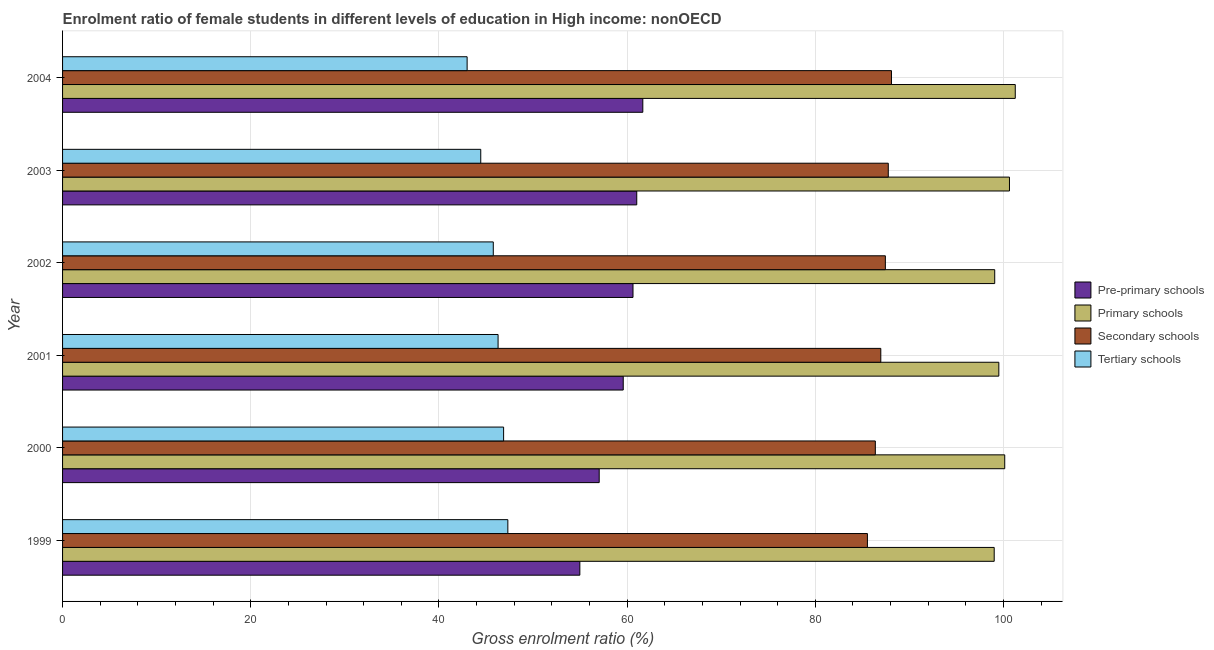How many groups of bars are there?
Your answer should be compact. 6. Are the number of bars per tick equal to the number of legend labels?
Make the answer very short. Yes. Are the number of bars on each tick of the Y-axis equal?
Your answer should be compact. Yes. How many bars are there on the 2nd tick from the top?
Offer a terse response. 4. How many bars are there on the 2nd tick from the bottom?
Provide a succinct answer. 4. What is the label of the 6th group of bars from the top?
Keep it short and to the point. 1999. In how many cases, is the number of bars for a given year not equal to the number of legend labels?
Keep it short and to the point. 0. What is the gross enrolment ratio(male) in secondary schools in 2003?
Offer a very short reply. 87.75. Across all years, what is the maximum gross enrolment ratio(male) in tertiary schools?
Provide a succinct answer. 47.32. Across all years, what is the minimum gross enrolment ratio(male) in pre-primary schools?
Offer a very short reply. 54.98. What is the total gross enrolment ratio(male) in secondary schools in the graph?
Provide a succinct answer. 522.16. What is the difference between the gross enrolment ratio(male) in pre-primary schools in 2001 and that in 2003?
Keep it short and to the point. -1.44. What is the difference between the gross enrolment ratio(male) in pre-primary schools in 2000 and the gross enrolment ratio(male) in tertiary schools in 2003?
Give a very brief answer. 12.59. What is the average gross enrolment ratio(male) in pre-primary schools per year?
Offer a terse response. 59.15. In the year 2002, what is the difference between the gross enrolment ratio(male) in primary schools and gross enrolment ratio(male) in tertiary schools?
Provide a succinct answer. 53.29. What is the ratio of the gross enrolment ratio(male) in pre-primary schools in 1999 to that in 2004?
Offer a very short reply. 0.89. Is the gross enrolment ratio(male) in tertiary schools in 2002 less than that in 2004?
Make the answer very short. No. What is the difference between the highest and the second highest gross enrolment ratio(male) in tertiary schools?
Ensure brevity in your answer.  0.45. What is the difference between the highest and the lowest gross enrolment ratio(male) in pre-primary schools?
Provide a succinct answer. 6.69. Is the sum of the gross enrolment ratio(male) in primary schools in 2000 and 2003 greater than the maximum gross enrolment ratio(male) in tertiary schools across all years?
Make the answer very short. Yes. Is it the case that in every year, the sum of the gross enrolment ratio(male) in pre-primary schools and gross enrolment ratio(male) in secondary schools is greater than the sum of gross enrolment ratio(male) in primary schools and gross enrolment ratio(male) in tertiary schools?
Offer a terse response. No. What does the 1st bar from the top in 2000 represents?
Give a very brief answer. Tertiary schools. What does the 3rd bar from the bottom in 2003 represents?
Keep it short and to the point. Secondary schools. How many years are there in the graph?
Provide a short and direct response. 6. Are the values on the major ticks of X-axis written in scientific E-notation?
Offer a terse response. No. Does the graph contain any zero values?
Your answer should be compact. No. How many legend labels are there?
Your answer should be compact. 4. How are the legend labels stacked?
Ensure brevity in your answer.  Vertical. What is the title of the graph?
Make the answer very short. Enrolment ratio of female students in different levels of education in High income: nonOECD. What is the Gross enrolment ratio (%) of Pre-primary schools in 1999?
Offer a terse response. 54.98. What is the Gross enrolment ratio (%) of Primary schools in 1999?
Provide a succinct answer. 99.01. What is the Gross enrolment ratio (%) in Secondary schools in 1999?
Provide a succinct answer. 85.54. What is the Gross enrolment ratio (%) in Tertiary schools in 1999?
Offer a very short reply. 47.32. What is the Gross enrolment ratio (%) in Pre-primary schools in 2000?
Your answer should be very brief. 57.03. What is the Gross enrolment ratio (%) in Primary schools in 2000?
Give a very brief answer. 100.13. What is the Gross enrolment ratio (%) of Secondary schools in 2000?
Your answer should be compact. 86.38. What is the Gross enrolment ratio (%) of Tertiary schools in 2000?
Keep it short and to the point. 46.87. What is the Gross enrolment ratio (%) in Pre-primary schools in 2001?
Make the answer very short. 59.59. What is the Gross enrolment ratio (%) in Primary schools in 2001?
Ensure brevity in your answer.  99.5. What is the Gross enrolment ratio (%) in Secondary schools in 2001?
Make the answer very short. 86.96. What is the Gross enrolment ratio (%) of Tertiary schools in 2001?
Provide a short and direct response. 46.29. What is the Gross enrolment ratio (%) in Pre-primary schools in 2002?
Offer a terse response. 60.62. What is the Gross enrolment ratio (%) in Primary schools in 2002?
Offer a terse response. 99.07. What is the Gross enrolment ratio (%) of Secondary schools in 2002?
Your answer should be compact. 87.44. What is the Gross enrolment ratio (%) of Tertiary schools in 2002?
Offer a very short reply. 45.78. What is the Gross enrolment ratio (%) in Pre-primary schools in 2003?
Make the answer very short. 61.02. What is the Gross enrolment ratio (%) in Primary schools in 2003?
Your response must be concise. 100.63. What is the Gross enrolment ratio (%) of Secondary schools in 2003?
Offer a very short reply. 87.75. What is the Gross enrolment ratio (%) in Tertiary schools in 2003?
Offer a very short reply. 44.44. What is the Gross enrolment ratio (%) of Pre-primary schools in 2004?
Give a very brief answer. 61.67. What is the Gross enrolment ratio (%) in Primary schools in 2004?
Your answer should be very brief. 101.25. What is the Gross enrolment ratio (%) of Secondary schools in 2004?
Give a very brief answer. 88.09. What is the Gross enrolment ratio (%) in Tertiary schools in 2004?
Provide a short and direct response. 42.99. Across all years, what is the maximum Gross enrolment ratio (%) of Pre-primary schools?
Your answer should be compact. 61.67. Across all years, what is the maximum Gross enrolment ratio (%) of Primary schools?
Give a very brief answer. 101.25. Across all years, what is the maximum Gross enrolment ratio (%) of Secondary schools?
Your answer should be very brief. 88.09. Across all years, what is the maximum Gross enrolment ratio (%) of Tertiary schools?
Give a very brief answer. 47.32. Across all years, what is the minimum Gross enrolment ratio (%) in Pre-primary schools?
Your response must be concise. 54.98. Across all years, what is the minimum Gross enrolment ratio (%) in Primary schools?
Make the answer very short. 99.01. Across all years, what is the minimum Gross enrolment ratio (%) of Secondary schools?
Your answer should be very brief. 85.54. Across all years, what is the minimum Gross enrolment ratio (%) of Tertiary schools?
Offer a terse response. 42.99. What is the total Gross enrolment ratio (%) in Pre-primary schools in the graph?
Your answer should be compact. 354.91. What is the total Gross enrolment ratio (%) of Primary schools in the graph?
Make the answer very short. 599.59. What is the total Gross enrolment ratio (%) of Secondary schools in the graph?
Keep it short and to the point. 522.16. What is the total Gross enrolment ratio (%) of Tertiary schools in the graph?
Provide a short and direct response. 273.69. What is the difference between the Gross enrolment ratio (%) of Pre-primary schools in 1999 and that in 2000?
Provide a succinct answer. -2.06. What is the difference between the Gross enrolment ratio (%) of Primary schools in 1999 and that in 2000?
Offer a very short reply. -1.12. What is the difference between the Gross enrolment ratio (%) in Secondary schools in 1999 and that in 2000?
Offer a very short reply. -0.84. What is the difference between the Gross enrolment ratio (%) of Tertiary schools in 1999 and that in 2000?
Your answer should be very brief. 0.45. What is the difference between the Gross enrolment ratio (%) of Pre-primary schools in 1999 and that in 2001?
Offer a terse response. -4.61. What is the difference between the Gross enrolment ratio (%) of Primary schools in 1999 and that in 2001?
Your answer should be compact. -0.49. What is the difference between the Gross enrolment ratio (%) of Secondary schools in 1999 and that in 2001?
Offer a very short reply. -1.42. What is the difference between the Gross enrolment ratio (%) of Tertiary schools in 1999 and that in 2001?
Keep it short and to the point. 1.04. What is the difference between the Gross enrolment ratio (%) in Pre-primary schools in 1999 and that in 2002?
Keep it short and to the point. -5.65. What is the difference between the Gross enrolment ratio (%) of Primary schools in 1999 and that in 2002?
Your answer should be compact. -0.05. What is the difference between the Gross enrolment ratio (%) of Secondary schools in 1999 and that in 2002?
Make the answer very short. -1.91. What is the difference between the Gross enrolment ratio (%) of Tertiary schools in 1999 and that in 2002?
Provide a short and direct response. 1.55. What is the difference between the Gross enrolment ratio (%) in Pre-primary schools in 1999 and that in 2003?
Make the answer very short. -6.05. What is the difference between the Gross enrolment ratio (%) of Primary schools in 1999 and that in 2003?
Your response must be concise. -1.62. What is the difference between the Gross enrolment ratio (%) in Secondary schools in 1999 and that in 2003?
Make the answer very short. -2.22. What is the difference between the Gross enrolment ratio (%) in Tertiary schools in 1999 and that in 2003?
Give a very brief answer. 2.88. What is the difference between the Gross enrolment ratio (%) in Pre-primary schools in 1999 and that in 2004?
Your answer should be very brief. -6.69. What is the difference between the Gross enrolment ratio (%) in Primary schools in 1999 and that in 2004?
Your answer should be very brief. -2.24. What is the difference between the Gross enrolment ratio (%) of Secondary schools in 1999 and that in 2004?
Keep it short and to the point. -2.56. What is the difference between the Gross enrolment ratio (%) in Tertiary schools in 1999 and that in 2004?
Make the answer very short. 4.33. What is the difference between the Gross enrolment ratio (%) of Pre-primary schools in 2000 and that in 2001?
Ensure brevity in your answer.  -2.55. What is the difference between the Gross enrolment ratio (%) in Primary schools in 2000 and that in 2001?
Keep it short and to the point. 0.63. What is the difference between the Gross enrolment ratio (%) in Secondary schools in 2000 and that in 2001?
Offer a very short reply. -0.58. What is the difference between the Gross enrolment ratio (%) of Tertiary schools in 2000 and that in 2001?
Give a very brief answer. 0.59. What is the difference between the Gross enrolment ratio (%) in Pre-primary schools in 2000 and that in 2002?
Make the answer very short. -3.59. What is the difference between the Gross enrolment ratio (%) of Primary schools in 2000 and that in 2002?
Your answer should be very brief. 1.06. What is the difference between the Gross enrolment ratio (%) of Secondary schools in 2000 and that in 2002?
Give a very brief answer. -1.07. What is the difference between the Gross enrolment ratio (%) of Tertiary schools in 2000 and that in 2002?
Make the answer very short. 1.1. What is the difference between the Gross enrolment ratio (%) of Pre-primary schools in 2000 and that in 2003?
Give a very brief answer. -3.99. What is the difference between the Gross enrolment ratio (%) in Primary schools in 2000 and that in 2003?
Provide a short and direct response. -0.5. What is the difference between the Gross enrolment ratio (%) of Secondary schools in 2000 and that in 2003?
Your answer should be very brief. -1.38. What is the difference between the Gross enrolment ratio (%) in Tertiary schools in 2000 and that in 2003?
Your answer should be very brief. 2.43. What is the difference between the Gross enrolment ratio (%) of Pre-primary schools in 2000 and that in 2004?
Make the answer very short. -4.63. What is the difference between the Gross enrolment ratio (%) in Primary schools in 2000 and that in 2004?
Your response must be concise. -1.12. What is the difference between the Gross enrolment ratio (%) of Secondary schools in 2000 and that in 2004?
Offer a very short reply. -1.71. What is the difference between the Gross enrolment ratio (%) in Tertiary schools in 2000 and that in 2004?
Keep it short and to the point. 3.88. What is the difference between the Gross enrolment ratio (%) of Pre-primary schools in 2001 and that in 2002?
Your answer should be very brief. -1.04. What is the difference between the Gross enrolment ratio (%) in Primary schools in 2001 and that in 2002?
Your answer should be very brief. 0.44. What is the difference between the Gross enrolment ratio (%) in Secondary schools in 2001 and that in 2002?
Provide a succinct answer. -0.48. What is the difference between the Gross enrolment ratio (%) in Tertiary schools in 2001 and that in 2002?
Your answer should be compact. 0.51. What is the difference between the Gross enrolment ratio (%) of Pre-primary schools in 2001 and that in 2003?
Your answer should be very brief. -1.44. What is the difference between the Gross enrolment ratio (%) in Primary schools in 2001 and that in 2003?
Ensure brevity in your answer.  -1.13. What is the difference between the Gross enrolment ratio (%) in Secondary schools in 2001 and that in 2003?
Offer a terse response. -0.8. What is the difference between the Gross enrolment ratio (%) of Tertiary schools in 2001 and that in 2003?
Your answer should be very brief. 1.84. What is the difference between the Gross enrolment ratio (%) of Pre-primary schools in 2001 and that in 2004?
Provide a succinct answer. -2.08. What is the difference between the Gross enrolment ratio (%) of Primary schools in 2001 and that in 2004?
Provide a short and direct response. -1.75. What is the difference between the Gross enrolment ratio (%) of Secondary schools in 2001 and that in 2004?
Keep it short and to the point. -1.13. What is the difference between the Gross enrolment ratio (%) of Tertiary schools in 2001 and that in 2004?
Give a very brief answer. 3.29. What is the difference between the Gross enrolment ratio (%) in Pre-primary schools in 2002 and that in 2003?
Offer a very short reply. -0.4. What is the difference between the Gross enrolment ratio (%) of Primary schools in 2002 and that in 2003?
Make the answer very short. -1.57. What is the difference between the Gross enrolment ratio (%) of Secondary schools in 2002 and that in 2003?
Your answer should be compact. -0.31. What is the difference between the Gross enrolment ratio (%) in Tertiary schools in 2002 and that in 2003?
Make the answer very short. 1.33. What is the difference between the Gross enrolment ratio (%) of Pre-primary schools in 2002 and that in 2004?
Your answer should be very brief. -1.04. What is the difference between the Gross enrolment ratio (%) in Primary schools in 2002 and that in 2004?
Offer a very short reply. -2.18. What is the difference between the Gross enrolment ratio (%) of Secondary schools in 2002 and that in 2004?
Make the answer very short. -0.65. What is the difference between the Gross enrolment ratio (%) of Tertiary schools in 2002 and that in 2004?
Provide a succinct answer. 2.78. What is the difference between the Gross enrolment ratio (%) in Pre-primary schools in 2003 and that in 2004?
Give a very brief answer. -0.64. What is the difference between the Gross enrolment ratio (%) of Primary schools in 2003 and that in 2004?
Your response must be concise. -0.62. What is the difference between the Gross enrolment ratio (%) in Secondary schools in 2003 and that in 2004?
Your response must be concise. -0.34. What is the difference between the Gross enrolment ratio (%) of Tertiary schools in 2003 and that in 2004?
Provide a short and direct response. 1.45. What is the difference between the Gross enrolment ratio (%) of Pre-primary schools in 1999 and the Gross enrolment ratio (%) of Primary schools in 2000?
Provide a succinct answer. -45.16. What is the difference between the Gross enrolment ratio (%) of Pre-primary schools in 1999 and the Gross enrolment ratio (%) of Secondary schools in 2000?
Your answer should be very brief. -31.4. What is the difference between the Gross enrolment ratio (%) of Pre-primary schools in 1999 and the Gross enrolment ratio (%) of Tertiary schools in 2000?
Make the answer very short. 8.1. What is the difference between the Gross enrolment ratio (%) of Primary schools in 1999 and the Gross enrolment ratio (%) of Secondary schools in 2000?
Give a very brief answer. 12.63. What is the difference between the Gross enrolment ratio (%) in Primary schools in 1999 and the Gross enrolment ratio (%) in Tertiary schools in 2000?
Your response must be concise. 52.14. What is the difference between the Gross enrolment ratio (%) of Secondary schools in 1999 and the Gross enrolment ratio (%) of Tertiary schools in 2000?
Make the answer very short. 38.66. What is the difference between the Gross enrolment ratio (%) in Pre-primary schools in 1999 and the Gross enrolment ratio (%) in Primary schools in 2001?
Ensure brevity in your answer.  -44.53. What is the difference between the Gross enrolment ratio (%) in Pre-primary schools in 1999 and the Gross enrolment ratio (%) in Secondary schools in 2001?
Your answer should be compact. -31.98. What is the difference between the Gross enrolment ratio (%) of Pre-primary schools in 1999 and the Gross enrolment ratio (%) of Tertiary schools in 2001?
Give a very brief answer. 8.69. What is the difference between the Gross enrolment ratio (%) of Primary schools in 1999 and the Gross enrolment ratio (%) of Secondary schools in 2001?
Your answer should be compact. 12.05. What is the difference between the Gross enrolment ratio (%) in Primary schools in 1999 and the Gross enrolment ratio (%) in Tertiary schools in 2001?
Give a very brief answer. 52.73. What is the difference between the Gross enrolment ratio (%) in Secondary schools in 1999 and the Gross enrolment ratio (%) in Tertiary schools in 2001?
Your answer should be compact. 39.25. What is the difference between the Gross enrolment ratio (%) of Pre-primary schools in 1999 and the Gross enrolment ratio (%) of Primary schools in 2002?
Provide a short and direct response. -44.09. What is the difference between the Gross enrolment ratio (%) of Pre-primary schools in 1999 and the Gross enrolment ratio (%) of Secondary schools in 2002?
Provide a short and direct response. -32.47. What is the difference between the Gross enrolment ratio (%) in Pre-primary schools in 1999 and the Gross enrolment ratio (%) in Tertiary schools in 2002?
Make the answer very short. 9.2. What is the difference between the Gross enrolment ratio (%) in Primary schools in 1999 and the Gross enrolment ratio (%) in Secondary schools in 2002?
Offer a terse response. 11.57. What is the difference between the Gross enrolment ratio (%) of Primary schools in 1999 and the Gross enrolment ratio (%) of Tertiary schools in 2002?
Make the answer very short. 53.24. What is the difference between the Gross enrolment ratio (%) of Secondary schools in 1999 and the Gross enrolment ratio (%) of Tertiary schools in 2002?
Your answer should be compact. 39.76. What is the difference between the Gross enrolment ratio (%) of Pre-primary schools in 1999 and the Gross enrolment ratio (%) of Primary schools in 2003?
Your answer should be compact. -45.66. What is the difference between the Gross enrolment ratio (%) of Pre-primary schools in 1999 and the Gross enrolment ratio (%) of Secondary schools in 2003?
Your response must be concise. -32.78. What is the difference between the Gross enrolment ratio (%) of Pre-primary schools in 1999 and the Gross enrolment ratio (%) of Tertiary schools in 2003?
Ensure brevity in your answer.  10.53. What is the difference between the Gross enrolment ratio (%) of Primary schools in 1999 and the Gross enrolment ratio (%) of Secondary schools in 2003?
Your answer should be compact. 11.26. What is the difference between the Gross enrolment ratio (%) in Primary schools in 1999 and the Gross enrolment ratio (%) in Tertiary schools in 2003?
Your answer should be compact. 54.57. What is the difference between the Gross enrolment ratio (%) in Secondary schools in 1999 and the Gross enrolment ratio (%) in Tertiary schools in 2003?
Keep it short and to the point. 41.09. What is the difference between the Gross enrolment ratio (%) of Pre-primary schools in 1999 and the Gross enrolment ratio (%) of Primary schools in 2004?
Your response must be concise. -46.27. What is the difference between the Gross enrolment ratio (%) of Pre-primary schools in 1999 and the Gross enrolment ratio (%) of Secondary schools in 2004?
Offer a very short reply. -33.12. What is the difference between the Gross enrolment ratio (%) in Pre-primary schools in 1999 and the Gross enrolment ratio (%) in Tertiary schools in 2004?
Give a very brief answer. 11.98. What is the difference between the Gross enrolment ratio (%) in Primary schools in 1999 and the Gross enrolment ratio (%) in Secondary schools in 2004?
Give a very brief answer. 10.92. What is the difference between the Gross enrolment ratio (%) of Primary schools in 1999 and the Gross enrolment ratio (%) of Tertiary schools in 2004?
Provide a succinct answer. 56.02. What is the difference between the Gross enrolment ratio (%) of Secondary schools in 1999 and the Gross enrolment ratio (%) of Tertiary schools in 2004?
Your answer should be very brief. 42.54. What is the difference between the Gross enrolment ratio (%) in Pre-primary schools in 2000 and the Gross enrolment ratio (%) in Primary schools in 2001?
Provide a succinct answer. -42.47. What is the difference between the Gross enrolment ratio (%) in Pre-primary schools in 2000 and the Gross enrolment ratio (%) in Secondary schools in 2001?
Offer a very short reply. -29.93. What is the difference between the Gross enrolment ratio (%) in Pre-primary schools in 2000 and the Gross enrolment ratio (%) in Tertiary schools in 2001?
Provide a succinct answer. 10.75. What is the difference between the Gross enrolment ratio (%) in Primary schools in 2000 and the Gross enrolment ratio (%) in Secondary schools in 2001?
Ensure brevity in your answer.  13.17. What is the difference between the Gross enrolment ratio (%) in Primary schools in 2000 and the Gross enrolment ratio (%) in Tertiary schools in 2001?
Ensure brevity in your answer.  53.85. What is the difference between the Gross enrolment ratio (%) in Secondary schools in 2000 and the Gross enrolment ratio (%) in Tertiary schools in 2001?
Your response must be concise. 40.09. What is the difference between the Gross enrolment ratio (%) of Pre-primary schools in 2000 and the Gross enrolment ratio (%) of Primary schools in 2002?
Ensure brevity in your answer.  -42.03. What is the difference between the Gross enrolment ratio (%) in Pre-primary schools in 2000 and the Gross enrolment ratio (%) in Secondary schools in 2002?
Your answer should be very brief. -30.41. What is the difference between the Gross enrolment ratio (%) of Pre-primary schools in 2000 and the Gross enrolment ratio (%) of Tertiary schools in 2002?
Your answer should be compact. 11.26. What is the difference between the Gross enrolment ratio (%) in Primary schools in 2000 and the Gross enrolment ratio (%) in Secondary schools in 2002?
Your answer should be compact. 12.69. What is the difference between the Gross enrolment ratio (%) of Primary schools in 2000 and the Gross enrolment ratio (%) of Tertiary schools in 2002?
Give a very brief answer. 54.35. What is the difference between the Gross enrolment ratio (%) in Secondary schools in 2000 and the Gross enrolment ratio (%) in Tertiary schools in 2002?
Provide a succinct answer. 40.6. What is the difference between the Gross enrolment ratio (%) of Pre-primary schools in 2000 and the Gross enrolment ratio (%) of Primary schools in 2003?
Offer a very short reply. -43.6. What is the difference between the Gross enrolment ratio (%) in Pre-primary schools in 2000 and the Gross enrolment ratio (%) in Secondary schools in 2003?
Your answer should be very brief. -30.72. What is the difference between the Gross enrolment ratio (%) in Pre-primary schools in 2000 and the Gross enrolment ratio (%) in Tertiary schools in 2003?
Give a very brief answer. 12.59. What is the difference between the Gross enrolment ratio (%) of Primary schools in 2000 and the Gross enrolment ratio (%) of Secondary schools in 2003?
Give a very brief answer. 12.38. What is the difference between the Gross enrolment ratio (%) in Primary schools in 2000 and the Gross enrolment ratio (%) in Tertiary schools in 2003?
Provide a short and direct response. 55.69. What is the difference between the Gross enrolment ratio (%) of Secondary schools in 2000 and the Gross enrolment ratio (%) of Tertiary schools in 2003?
Give a very brief answer. 41.93. What is the difference between the Gross enrolment ratio (%) of Pre-primary schools in 2000 and the Gross enrolment ratio (%) of Primary schools in 2004?
Provide a succinct answer. -44.22. What is the difference between the Gross enrolment ratio (%) of Pre-primary schools in 2000 and the Gross enrolment ratio (%) of Secondary schools in 2004?
Offer a terse response. -31.06. What is the difference between the Gross enrolment ratio (%) of Pre-primary schools in 2000 and the Gross enrolment ratio (%) of Tertiary schools in 2004?
Give a very brief answer. 14.04. What is the difference between the Gross enrolment ratio (%) of Primary schools in 2000 and the Gross enrolment ratio (%) of Secondary schools in 2004?
Provide a short and direct response. 12.04. What is the difference between the Gross enrolment ratio (%) in Primary schools in 2000 and the Gross enrolment ratio (%) in Tertiary schools in 2004?
Your response must be concise. 57.14. What is the difference between the Gross enrolment ratio (%) of Secondary schools in 2000 and the Gross enrolment ratio (%) of Tertiary schools in 2004?
Ensure brevity in your answer.  43.38. What is the difference between the Gross enrolment ratio (%) of Pre-primary schools in 2001 and the Gross enrolment ratio (%) of Primary schools in 2002?
Provide a succinct answer. -39.48. What is the difference between the Gross enrolment ratio (%) in Pre-primary schools in 2001 and the Gross enrolment ratio (%) in Secondary schools in 2002?
Your answer should be compact. -27.86. What is the difference between the Gross enrolment ratio (%) in Pre-primary schools in 2001 and the Gross enrolment ratio (%) in Tertiary schools in 2002?
Your answer should be compact. 13.81. What is the difference between the Gross enrolment ratio (%) of Primary schools in 2001 and the Gross enrolment ratio (%) of Secondary schools in 2002?
Ensure brevity in your answer.  12.06. What is the difference between the Gross enrolment ratio (%) of Primary schools in 2001 and the Gross enrolment ratio (%) of Tertiary schools in 2002?
Ensure brevity in your answer.  53.73. What is the difference between the Gross enrolment ratio (%) of Secondary schools in 2001 and the Gross enrolment ratio (%) of Tertiary schools in 2002?
Provide a succinct answer. 41.18. What is the difference between the Gross enrolment ratio (%) in Pre-primary schools in 2001 and the Gross enrolment ratio (%) in Primary schools in 2003?
Make the answer very short. -41.05. What is the difference between the Gross enrolment ratio (%) of Pre-primary schools in 2001 and the Gross enrolment ratio (%) of Secondary schools in 2003?
Your answer should be compact. -28.17. What is the difference between the Gross enrolment ratio (%) in Pre-primary schools in 2001 and the Gross enrolment ratio (%) in Tertiary schools in 2003?
Give a very brief answer. 15.14. What is the difference between the Gross enrolment ratio (%) of Primary schools in 2001 and the Gross enrolment ratio (%) of Secondary schools in 2003?
Your answer should be compact. 11.75. What is the difference between the Gross enrolment ratio (%) in Primary schools in 2001 and the Gross enrolment ratio (%) in Tertiary schools in 2003?
Your answer should be compact. 55.06. What is the difference between the Gross enrolment ratio (%) in Secondary schools in 2001 and the Gross enrolment ratio (%) in Tertiary schools in 2003?
Ensure brevity in your answer.  42.52. What is the difference between the Gross enrolment ratio (%) in Pre-primary schools in 2001 and the Gross enrolment ratio (%) in Primary schools in 2004?
Your response must be concise. -41.66. What is the difference between the Gross enrolment ratio (%) in Pre-primary schools in 2001 and the Gross enrolment ratio (%) in Secondary schools in 2004?
Make the answer very short. -28.51. What is the difference between the Gross enrolment ratio (%) in Pre-primary schools in 2001 and the Gross enrolment ratio (%) in Tertiary schools in 2004?
Offer a very short reply. 16.59. What is the difference between the Gross enrolment ratio (%) of Primary schools in 2001 and the Gross enrolment ratio (%) of Secondary schools in 2004?
Your answer should be compact. 11.41. What is the difference between the Gross enrolment ratio (%) of Primary schools in 2001 and the Gross enrolment ratio (%) of Tertiary schools in 2004?
Give a very brief answer. 56.51. What is the difference between the Gross enrolment ratio (%) in Secondary schools in 2001 and the Gross enrolment ratio (%) in Tertiary schools in 2004?
Keep it short and to the point. 43.96. What is the difference between the Gross enrolment ratio (%) in Pre-primary schools in 2002 and the Gross enrolment ratio (%) in Primary schools in 2003?
Give a very brief answer. -40.01. What is the difference between the Gross enrolment ratio (%) of Pre-primary schools in 2002 and the Gross enrolment ratio (%) of Secondary schools in 2003?
Keep it short and to the point. -27.13. What is the difference between the Gross enrolment ratio (%) in Pre-primary schools in 2002 and the Gross enrolment ratio (%) in Tertiary schools in 2003?
Provide a short and direct response. 16.18. What is the difference between the Gross enrolment ratio (%) in Primary schools in 2002 and the Gross enrolment ratio (%) in Secondary schools in 2003?
Make the answer very short. 11.31. What is the difference between the Gross enrolment ratio (%) in Primary schools in 2002 and the Gross enrolment ratio (%) in Tertiary schools in 2003?
Give a very brief answer. 54.62. What is the difference between the Gross enrolment ratio (%) in Secondary schools in 2002 and the Gross enrolment ratio (%) in Tertiary schools in 2003?
Your answer should be very brief. 43. What is the difference between the Gross enrolment ratio (%) of Pre-primary schools in 2002 and the Gross enrolment ratio (%) of Primary schools in 2004?
Offer a terse response. -40.63. What is the difference between the Gross enrolment ratio (%) of Pre-primary schools in 2002 and the Gross enrolment ratio (%) of Secondary schools in 2004?
Your response must be concise. -27.47. What is the difference between the Gross enrolment ratio (%) in Pre-primary schools in 2002 and the Gross enrolment ratio (%) in Tertiary schools in 2004?
Keep it short and to the point. 17.63. What is the difference between the Gross enrolment ratio (%) of Primary schools in 2002 and the Gross enrolment ratio (%) of Secondary schools in 2004?
Offer a terse response. 10.97. What is the difference between the Gross enrolment ratio (%) of Primary schools in 2002 and the Gross enrolment ratio (%) of Tertiary schools in 2004?
Provide a succinct answer. 56.07. What is the difference between the Gross enrolment ratio (%) in Secondary schools in 2002 and the Gross enrolment ratio (%) in Tertiary schools in 2004?
Your response must be concise. 44.45. What is the difference between the Gross enrolment ratio (%) of Pre-primary schools in 2003 and the Gross enrolment ratio (%) of Primary schools in 2004?
Offer a very short reply. -40.23. What is the difference between the Gross enrolment ratio (%) in Pre-primary schools in 2003 and the Gross enrolment ratio (%) in Secondary schools in 2004?
Offer a terse response. -27.07. What is the difference between the Gross enrolment ratio (%) of Pre-primary schools in 2003 and the Gross enrolment ratio (%) of Tertiary schools in 2004?
Your answer should be compact. 18.03. What is the difference between the Gross enrolment ratio (%) of Primary schools in 2003 and the Gross enrolment ratio (%) of Secondary schools in 2004?
Your response must be concise. 12.54. What is the difference between the Gross enrolment ratio (%) of Primary schools in 2003 and the Gross enrolment ratio (%) of Tertiary schools in 2004?
Your response must be concise. 57.64. What is the difference between the Gross enrolment ratio (%) of Secondary schools in 2003 and the Gross enrolment ratio (%) of Tertiary schools in 2004?
Give a very brief answer. 44.76. What is the average Gross enrolment ratio (%) of Pre-primary schools per year?
Ensure brevity in your answer.  59.15. What is the average Gross enrolment ratio (%) of Primary schools per year?
Ensure brevity in your answer.  99.93. What is the average Gross enrolment ratio (%) of Secondary schools per year?
Offer a terse response. 87.03. What is the average Gross enrolment ratio (%) in Tertiary schools per year?
Your response must be concise. 45.62. In the year 1999, what is the difference between the Gross enrolment ratio (%) of Pre-primary schools and Gross enrolment ratio (%) of Primary schools?
Keep it short and to the point. -44.04. In the year 1999, what is the difference between the Gross enrolment ratio (%) of Pre-primary schools and Gross enrolment ratio (%) of Secondary schools?
Your response must be concise. -30.56. In the year 1999, what is the difference between the Gross enrolment ratio (%) of Pre-primary schools and Gross enrolment ratio (%) of Tertiary schools?
Make the answer very short. 7.65. In the year 1999, what is the difference between the Gross enrolment ratio (%) in Primary schools and Gross enrolment ratio (%) in Secondary schools?
Your answer should be very brief. 13.47. In the year 1999, what is the difference between the Gross enrolment ratio (%) of Primary schools and Gross enrolment ratio (%) of Tertiary schools?
Your response must be concise. 51.69. In the year 1999, what is the difference between the Gross enrolment ratio (%) in Secondary schools and Gross enrolment ratio (%) in Tertiary schools?
Ensure brevity in your answer.  38.21. In the year 2000, what is the difference between the Gross enrolment ratio (%) of Pre-primary schools and Gross enrolment ratio (%) of Primary schools?
Provide a short and direct response. -43.1. In the year 2000, what is the difference between the Gross enrolment ratio (%) of Pre-primary schools and Gross enrolment ratio (%) of Secondary schools?
Keep it short and to the point. -29.35. In the year 2000, what is the difference between the Gross enrolment ratio (%) of Pre-primary schools and Gross enrolment ratio (%) of Tertiary schools?
Your response must be concise. 10.16. In the year 2000, what is the difference between the Gross enrolment ratio (%) of Primary schools and Gross enrolment ratio (%) of Secondary schools?
Your response must be concise. 13.75. In the year 2000, what is the difference between the Gross enrolment ratio (%) in Primary schools and Gross enrolment ratio (%) in Tertiary schools?
Provide a succinct answer. 53.26. In the year 2000, what is the difference between the Gross enrolment ratio (%) of Secondary schools and Gross enrolment ratio (%) of Tertiary schools?
Your response must be concise. 39.51. In the year 2001, what is the difference between the Gross enrolment ratio (%) in Pre-primary schools and Gross enrolment ratio (%) in Primary schools?
Offer a terse response. -39.92. In the year 2001, what is the difference between the Gross enrolment ratio (%) in Pre-primary schools and Gross enrolment ratio (%) in Secondary schools?
Provide a short and direct response. -27.37. In the year 2001, what is the difference between the Gross enrolment ratio (%) in Pre-primary schools and Gross enrolment ratio (%) in Tertiary schools?
Give a very brief answer. 13.3. In the year 2001, what is the difference between the Gross enrolment ratio (%) in Primary schools and Gross enrolment ratio (%) in Secondary schools?
Make the answer very short. 12.54. In the year 2001, what is the difference between the Gross enrolment ratio (%) in Primary schools and Gross enrolment ratio (%) in Tertiary schools?
Provide a short and direct response. 53.22. In the year 2001, what is the difference between the Gross enrolment ratio (%) of Secondary schools and Gross enrolment ratio (%) of Tertiary schools?
Make the answer very short. 40.67. In the year 2002, what is the difference between the Gross enrolment ratio (%) in Pre-primary schools and Gross enrolment ratio (%) in Primary schools?
Offer a terse response. -38.44. In the year 2002, what is the difference between the Gross enrolment ratio (%) in Pre-primary schools and Gross enrolment ratio (%) in Secondary schools?
Keep it short and to the point. -26.82. In the year 2002, what is the difference between the Gross enrolment ratio (%) of Pre-primary schools and Gross enrolment ratio (%) of Tertiary schools?
Provide a succinct answer. 14.85. In the year 2002, what is the difference between the Gross enrolment ratio (%) in Primary schools and Gross enrolment ratio (%) in Secondary schools?
Your answer should be very brief. 11.62. In the year 2002, what is the difference between the Gross enrolment ratio (%) of Primary schools and Gross enrolment ratio (%) of Tertiary schools?
Provide a short and direct response. 53.29. In the year 2002, what is the difference between the Gross enrolment ratio (%) of Secondary schools and Gross enrolment ratio (%) of Tertiary schools?
Give a very brief answer. 41.67. In the year 2003, what is the difference between the Gross enrolment ratio (%) in Pre-primary schools and Gross enrolment ratio (%) in Primary schools?
Your answer should be compact. -39.61. In the year 2003, what is the difference between the Gross enrolment ratio (%) in Pre-primary schools and Gross enrolment ratio (%) in Secondary schools?
Provide a succinct answer. -26.73. In the year 2003, what is the difference between the Gross enrolment ratio (%) of Pre-primary schools and Gross enrolment ratio (%) of Tertiary schools?
Ensure brevity in your answer.  16.58. In the year 2003, what is the difference between the Gross enrolment ratio (%) of Primary schools and Gross enrolment ratio (%) of Secondary schools?
Your answer should be compact. 12.88. In the year 2003, what is the difference between the Gross enrolment ratio (%) of Primary schools and Gross enrolment ratio (%) of Tertiary schools?
Give a very brief answer. 56.19. In the year 2003, what is the difference between the Gross enrolment ratio (%) of Secondary schools and Gross enrolment ratio (%) of Tertiary schools?
Ensure brevity in your answer.  43.31. In the year 2004, what is the difference between the Gross enrolment ratio (%) in Pre-primary schools and Gross enrolment ratio (%) in Primary schools?
Your response must be concise. -39.58. In the year 2004, what is the difference between the Gross enrolment ratio (%) in Pre-primary schools and Gross enrolment ratio (%) in Secondary schools?
Your answer should be very brief. -26.43. In the year 2004, what is the difference between the Gross enrolment ratio (%) in Pre-primary schools and Gross enrolment ratio (%) in Tertiary schools?
Keep it short and to the point. 18.67. In the year 2004, what is the difference between the Gross enrolment ratio (%) of Primary schools and Gross enrolment ratio (%) of Secondary schools?
Provide a succinct answer. 13.16. In the year 2004, what is the difference between the Gross enrolment ratio (%) of Primary schools and Gross enrolment ratio (%) of Tertiary schools?
Your answer should be very brief. 58.25. In the year 2004, what is the difference between the Gross enrolment ratio (%) of Secondary schools and Gross enrolment ratio (%) of Tertiary schools?
Provide a succinct answer. 45.1. What is the ratio of the Gross enrolment ratio (%) of Pre-primary schools in 1999 to that in 2000?
Provide a short and direct response. 0.96. What is the ratio of the Gross enrolment ratio (%) in Primary schools in 1999 to that in 2000?
Your response must be concise. 0.99. What is the ratio of the Gross enrolment ratio (%) in Secondary schools in 1999 to that in 2000?
Keep it short and to the point. 0.99. What is the ratio of the Gross enrolment ratio (%) of Tertiary schools in 1999 to that in 2000?
Provide a short and direct response. 1.01. What is the ratio of the Gross enrolment ratio (%) in Pre-primary schools in 1999 to that in 2001?
Keep it short and to the point. 0.92. What is the ratio of the Gross enrolment ratio (%) of Secondary schools in 1999 to that in 2001?
Ensure brevity in your answer.  0.98. What is the ratio of the Gross enrolment ratio (%) of Tertiary schools in 1999 to that in 2001?
Your answer should be very brief. 1.02. What is the ratio of the Gross enrolment ratio (%) in Pre-primary schools in 1999 to that in 2002?
Keep it short and to the point. 0.91. What is the ratio of the Gross enrolment ratio (%) in Primary schools in 1999 to that in 2002?
Your response must be concise. 1. What is the ratio of the Gross enrolment ratio (%) in Secondary schools in 1999 to that in 2002?
Keep it short and to the point. 0.98. What is the ratio of the Gross enrolment ratio (%) in Tertiary schools in 1999 to that in 2002?
Provide a short and direct response. 1.03. What is the ratio of the Gross enrolment ratio (%) of Pre-primary schools in 1999 to that in 2003?
Provide a short and direct response. 0.9. What is the ratio of the Gross enrolment ratio (%) in Primary schools in 1999 to that in 2003?
Your answer should be very brief. 0.98. What is the ratio of the Gross enrolment ratio (%) in Secondary schools in 1999 to that in 2003?
Offer a very short reply. 0.97. What is the ratio of the Gross enrolment ratio (%) in Tertiary schools in 1999 to that in 2003?
Give a very brief answer. 1.06. What is the ratio of the Gross enrolment ratio (%) in Pre-primary schools in 1999 to that in 2004?
Keep it short and to the point. 0.89. What is the ratio of the Gross enrolment ratio (%) in Primary schools in 1999 to that in 2004?
Keep it short and to the point. 0.98. What is the ratio of the Gross enrolment ratio (%) in Tertiary schools in 1999 to that in 2004?
Your answer should be very brief. 1.1. What is the ratio of the Gross enrolment ratio (%) in Pre-primary schools in 2000 to that in 2001?
Make the answer very short. 0.96. What is the ratio of the Gross enrolment ratio (%) of Primary schools in 2000 to that in 2001?
Offer a terse response. 1.01. What is the ratio of the Gross enrolment ratio (%) of Tertiary schools in 2000 to that in 2001?
Your answer should be compact. 1.01. What is the ratio of the Gross enrolment ratio (%) of Pre-primary schools in 2000 to that in 2002?
Offer a terse response. 0.94. What is the ratio of the Gross enrolment ratio (%) of Primary schools in 2000 to that in 2002?
Your response must be concise. 1.01. What is the ratio of the Gross enrolment ratio (%) in Secondary schools in 2000 to that in 2002?
Ensure brevity in your answer.  0.99. What is the ratio of the Gross enrolment ratio (%) of Pre-primary schools in 2000 to that in 2003?
Provide a succinct answer. 0.93. What is the ratio of the Gross enrolment ratio (%) of Primary schools in 2000 to that in 2003?
Provide a short and direct response. 0.99. What is the ratio of the Gross enrolment ratio (%) in Secondary schools in 2000 to that in 2003?
Offer a very short reply. 0.98. What is the ratio of the Gross enrolment ratio (%) in Tertiary schools in 2000 to that in 2003?
Your response must be concise. 1.05. What is the ratio of the Gross enrolment ratio (%) in Pre-primary schools in 2000 to that in 2004?
Offer a terse response. 0.92. What is the ratio of the Gross enrolment ratio (%) of Primary schools in 2000 to that in 2004?
Your response must be concise. 0.99. What is the ratio of the Gross enrolment ratio (%) in Secondary schools in 2000 to that in 2004?
Give a very brief answer. 0.98. What is the ratio of the Gross enrolment ratio (%) in Tertiary schools in 2000 to that in 2004?
Your answer should be compact. 1.09. What is the ratio of the Gross enrolment ratio (%) of Pre-primary schools in 2001 to that in 2002?
Offer a terse response. 0.98. What is the ratio of the Gross enrolment ratio (%) in Tertiary schools in 2001 to that in 2002?
Your answer should be very brief. 1.01. What is the ratio of the Gross enrolment ratio (%) in Pre-primary schools in 2001 to that in 2003?
Offer a terse response. 0.98. What is the ratio of the Gross enrolment ratio (%) of Secondary schools in 2001 to that in 2003?
Keep it short and to the point. 0.99. What is the ratio of the Gross enrolment ratio (%) of Tertiary schools in 2001 to that in 2003?
Give a very brief answer. 1.04. What is the ratio of the Gross enrolment ratio (%) in Pre-primary schools in 2001 to that in 2004?
Your answer should be very brief. 0.97. What is the ratio of the Gross enrolment ratio (%) of Primary schools in 2001 to that in 2004?
Make the answer very short. 0.98. What is the ratio of the Gross enrolment ratio (%) in Secondary schools in 2001 to that in 2004?
Offer a very short reply. 0.99. What is the ratio of the Gross enrolment ratio (%) in Tertiary schools in 2001 to that in 2004?
Your answer should be compact. 1.08. What is the ratio of the Gross enrolment ratio (%) in Primary schools in 2002 to that in 2003?
Ensure brevity in your answer.  0.98. What is the ratio of the Gross enrolment ratio (%) of Pre-primary schools in 2002 to that in 2004?
Offer a very short reply. 0.98. What is the ratio of the Gross enrolment ratio (%) in Primary schools in 2002 to that in 2004?
Provide a short and direct response. 0.98. What is the ratio of the Gross enrolment ratio (%) in Tertiary schools in 2002 to that in 2004?
Provide a succinct answer. 1.06. What is the ratio of the Gross enrolment ratio (%) of Pre-primary schools in 2003 to that in 2004?
Provide a short and direct response. 0.99. What is the ratio of the Gross enrolment ratio (%) of Primary schools in 2003 to that in 2004?
Ensure brevity in your answer.  0.99. What is the ratio of the Gross enrolment ratio (%) in Tertiary schools in 2003 to that in 2004?
Your answer should be compact. 1.03. What is the difference between the highest and the second highest Gross enrolment ratio (%) in Pre-primary schools?
Your answer should be compact. 0.64. What is the difference between the highest and the second highest Gross enrolment ratio (%) in Primary schools?
Provide a short and direct response. 0.62. What is the difference between the highest and the second highest Gross enrolment ratio (%) of Secondary schools?
Provide a succinct answer. 0.34. What is the difference between the highest and the second highest Gross enrolment ratio (%) of Tertiary schools?
Give a very brief answer. 0.45. What is the difference between the highest and the lowest Gross enrolment ratio (%) of Pre-primary schools?
Offer a terse response. 6.69. What is the difference between the highest and the lowest Gross enrolment ratio (%) in Primary schools?
Ensure brevity in your answer.  2.24. What is the difference between the highest and the lowest Gross enrolment ratio (%) in Secondary schools?
Give a very brief answer. 2.56. What is the difference between the highest and the lowest Gross enrolment ratio (%) in Tertiary schools?
Offer a very short reply. 4.33. 